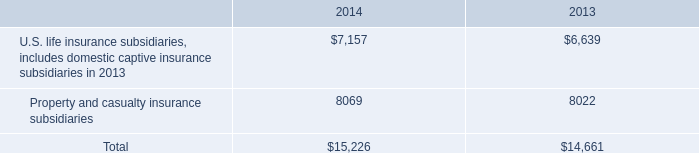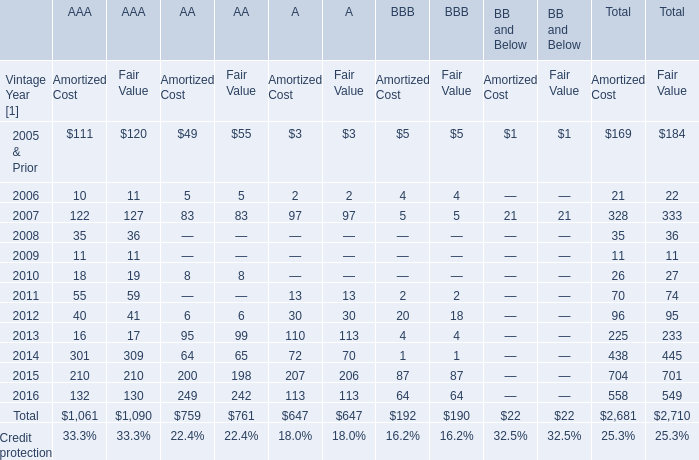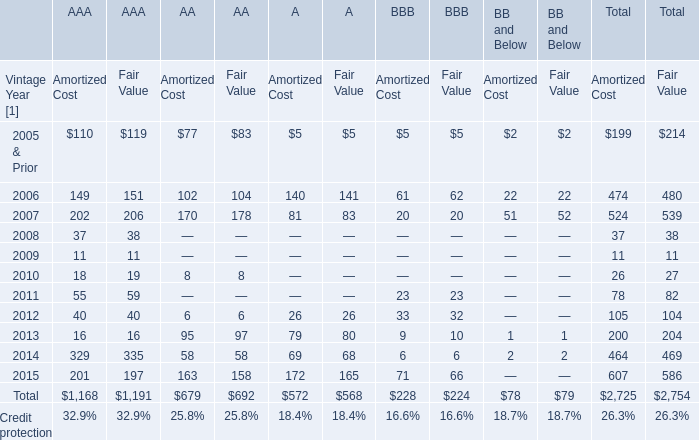what was the average statutory surplus for the company 2019s insurance companies for u.s . life insurance subsidiaries including domestic captive insurance subsidiaries from 2012 to 2013 
Computations: ((7157 + 6639) / 2)
Answer: 6898.0. 